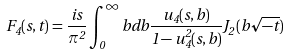Convert formula to latex. <formula><loc_0><loc_0><loc_500><loc_500>F _ { 4 } ( s , t ) = \frac { i s } { \pi ^ { 2 } } \int _ { 0 } ^ { \infty } b d b \frac { u _ { 4 } ( s , b ) } { 1 - u _ { 4 } ^ { 2 } ( s , b ) } J _ { 2 } ( b \sqrt { - t } )</formula> 